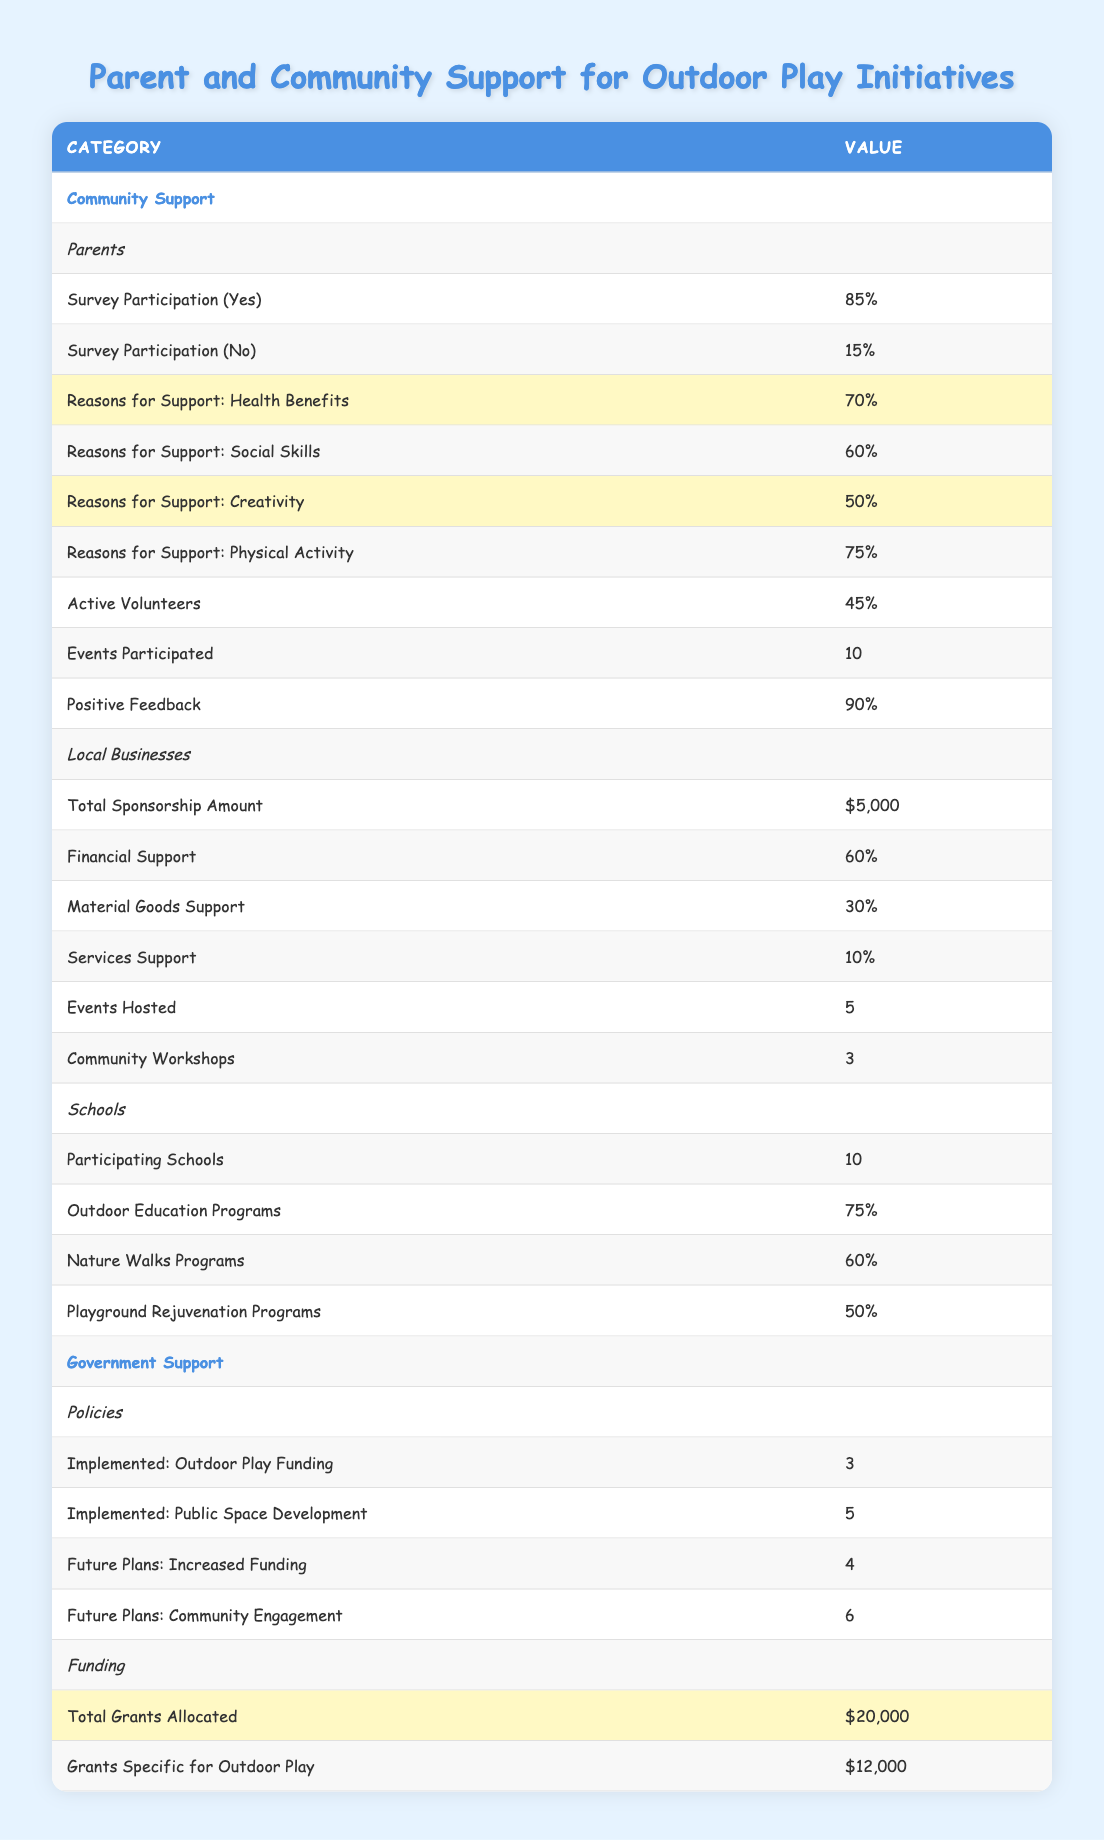What percentage of parents participated in the survey? The table states that 85% of parents answered "Yes" to participating in the survey. Therefore, the percentage of parents who participated is 85%.
Answer: 85% What are the main health benefits that parents support for outdoor play? From the table, the reasons listed for supporting outdoor play show that 70% of parents value health benefits, making it the most cited reason for support among other factors.
Answer: Health Benefits: 70% How many active volunteers are there among parents? The table clearly indicates that there are 45 active volunteers among the parents, as listed under the volunteering section.
Answer: 45 What is the total amount of sponsorship received from local businesses? According to the table, the total sponsorship amount received from local businesses is $5,000, as stated in the sponsorships section.
Answer: $5,000 What percentage of feedback from parents about outdoor play initiatives was positive? The table shows that 90% of the feedback from parents is positive, indicating strong support for outdoor play initiatives among those who volunteered and participated.
Answer: 90% If the total grants allocated is $20,000, how much is specifically for outdoor play? The table indicates that out of the total grants of $20,000, $12,000 is specifically allocated for outdoor play. Therefore, the answer is a direct extraction from the funding section.
Answer: $12,000 Are there more outdoor education programs implemented compared to nature walks? From the data in the table, 75% of outdoor education programs are implemented compared to 60% of nature walks. Thus, there are indeed more outdoor education programs than nature walks.
Answer: Yes What is the ratio of implemented public space development to outdoor play funding? The table indicates that there are 5 implemented public space developments and 3 outdoor play funding projects. The ratio can be calculated as 5:3. This means for every 5 public space projects, there are 3 outdoor play funding projects.
Answer: 5:3 How many community workshops have local businesses hosted? The table lists that local businesses have hosted 3 community workshops. This is a straightforward retrieval from the engagement section.
Answer: 3 What are the future plans for government support regarding community engagement? According to the table, future plans for government support include 6 initiatives focused on community engagement. This reflects the government's ongoing commitment to enhance outdoor play opportunities through community involvement.
Answer: 6 